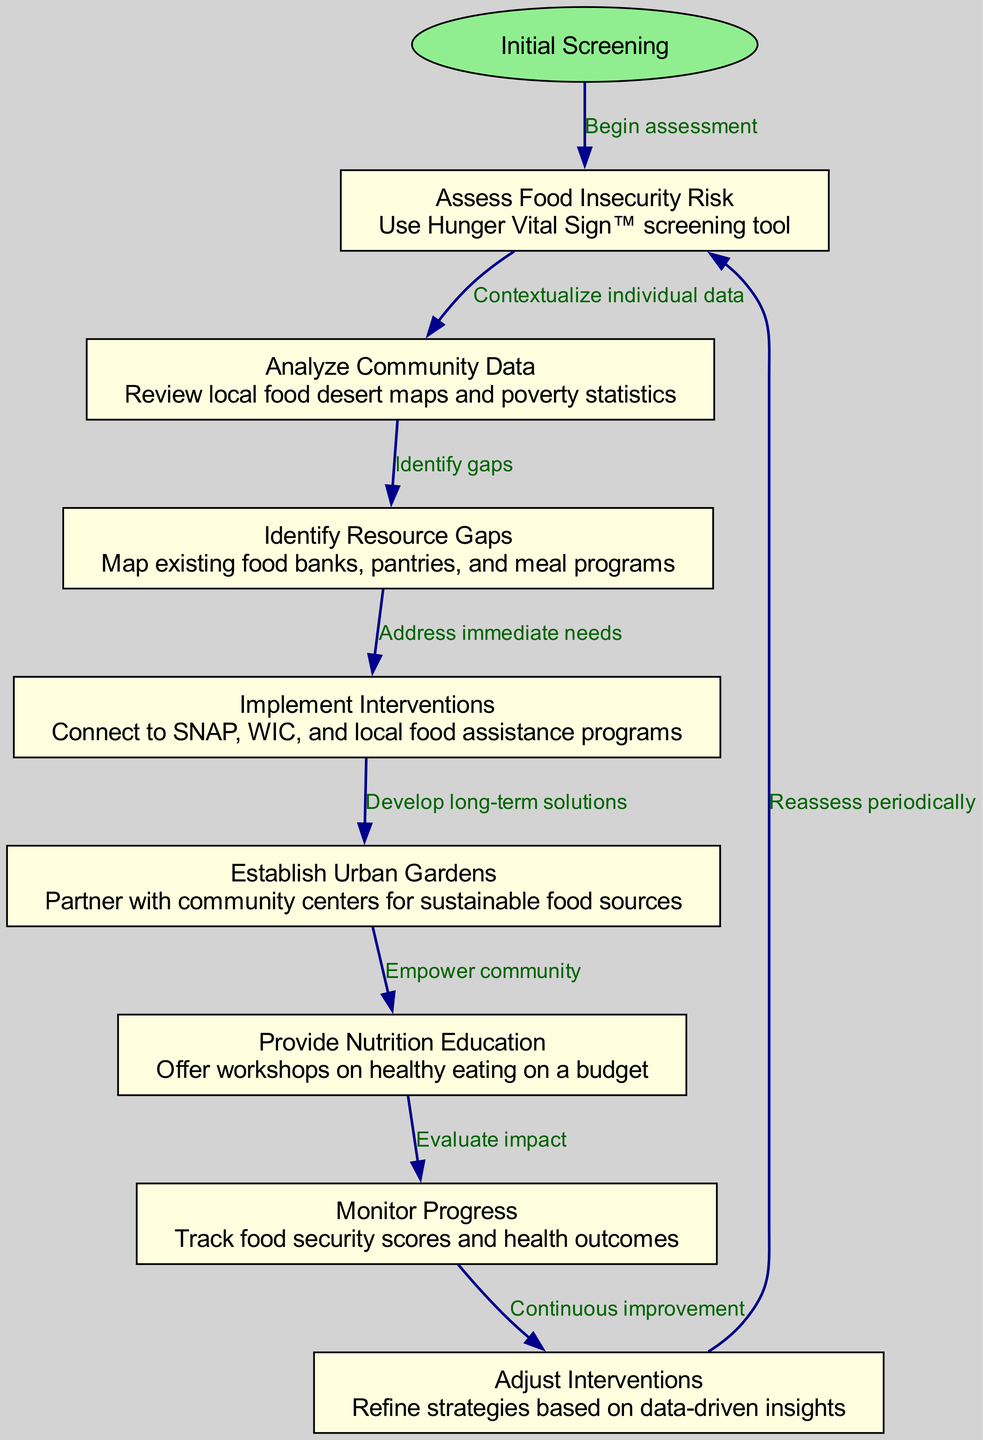What is the first step in the clinical pathway? The first step in the clinical pathway is labeled as "Initial Screening," which serves as the starting point for assessing food insecurity.
Answer: Initial Screening How many nodes are present in the diagram? By counting the individual nodes listed in the data, there are a total of 8 nodes (including the start node).
Answer: 8 What intervention follows the assessment of food insecurity risk? The intervention that follows the assessment of food insecurity risk is "Analyze Community Data," which is the next step after the initial assessment.
Answer: Analyze Community Data What is the purpose of the "Monitor Progress" step? The "Monitor Progress" step is designed to track food security scores and health outcomes to evaluate the effectiveness of interventions implemented earlier in the pathway.
Answer: Track food security scores and health outcomes How does "Establish Urban Gardens" relate to "Implement Interventions"? The "Establish Urban Gardens" step is a follow-up action that develops long-term solutions after the "Implement Interventions" step, indicating a progression from immediate assistance to sustainable solutions.
Answer: Develop long-term solutions What continuous process is indicated after monitoring progress? After monitoring progress, the pathway indicates an ongoing process known as "Adjust Interventions," which signifies the need for continuous improvement based on the data collected.
Answer: Adjust Interventions What tools are used in the "Assess Food Insecurity Risk" step? The tools used in the "Assess Food Insecurity Risk" step include the Hunger Vital Sign™ screening tool, which assists in determining the risk of food insecurity among individuals.
Answer: Hunger Vital Sign™ Which step involves connecting to SNAP and WIC? The step that involves connecting to SNAP, WIC, and local food assistance programs is titled "Implement Interventions." This step aims to address immediate food needs.
Answer: Implement Interventions What is the final step in the assessment process? The final step in the assessment process is "Reassess periodically," which signifies the importance of reviewing the situation after implementing the interventions for food insecurity.
Answer: Reassess periodically 